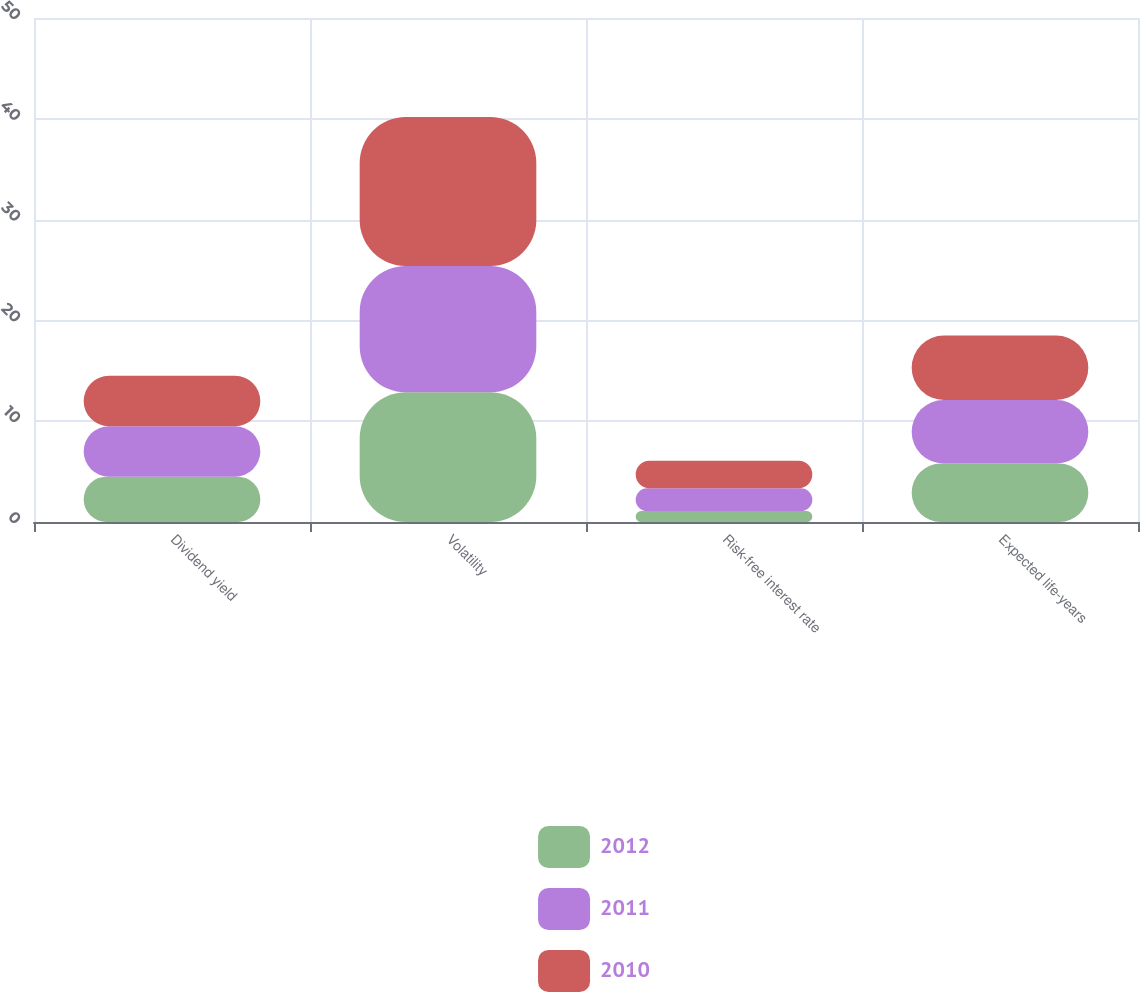Convert chart to OTSL. <chart><loc_0><loc_0><loc_500><loc_500><stacked_bar_chart><ecel><fcel>Dividend yield<fcel>Volatility<fcel>Risk-free interest rate<fcel>Expected life-years<nl><fcel>2012<fcel>4.5<fcel>12.86<fcel>1.08<fcel>5.8<nl><fcel>2011<fcel>5<fcel>12.54<fcel>2.26<fcel>6.3<nl><fcel>2010<fcel>5<fcel>14.77<fcel>2.74<fcel>6.4<nl></chart> 